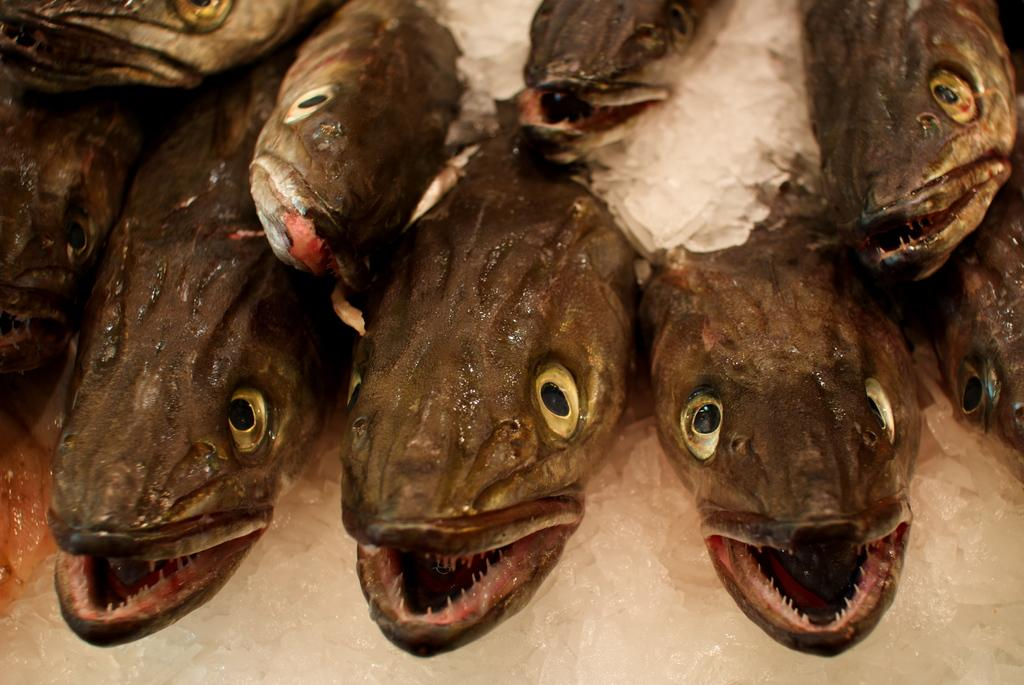What type of animals can be seen in the image? There are fishes in the image. What is located at the bottom of the image? There is an ice block at the bottom of the image. What type of wrist accessory is visible on the fishes in the image? There is no wrist accessory present on the fishes in the image. Is there a baseball game happening in the image? There is no baseball game or any reference to sports in the image. 